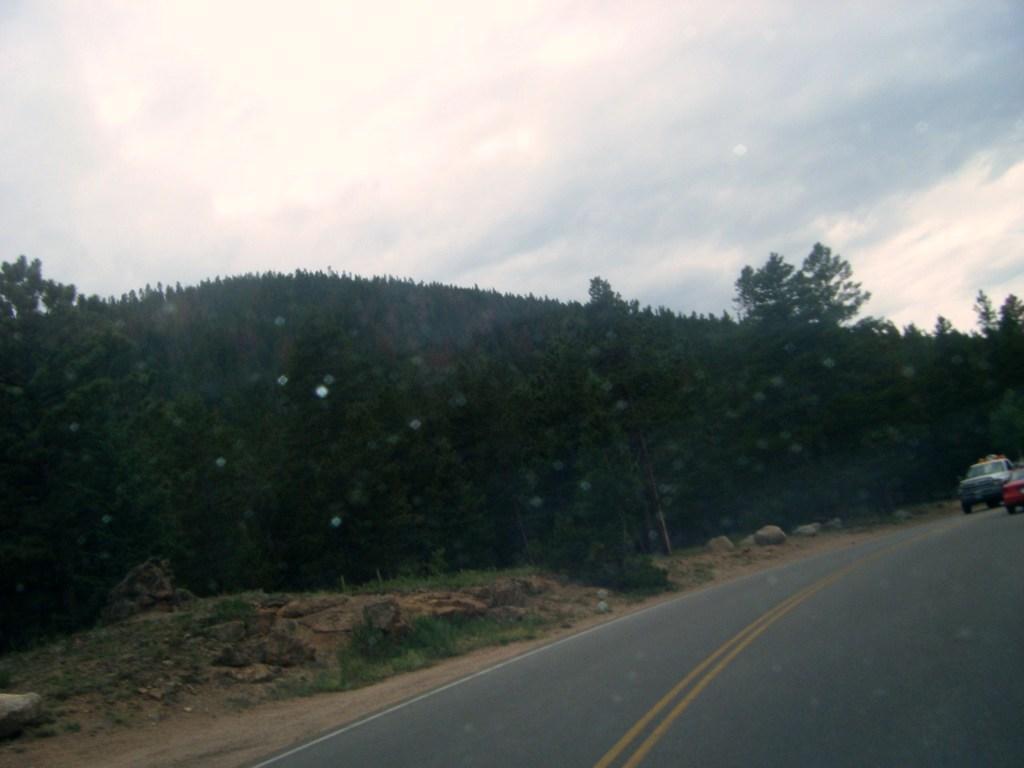In one or two sentences, can you explain what this image depicts? In the image there are a lot of trees beside the road and there are two vehicles on the road. 